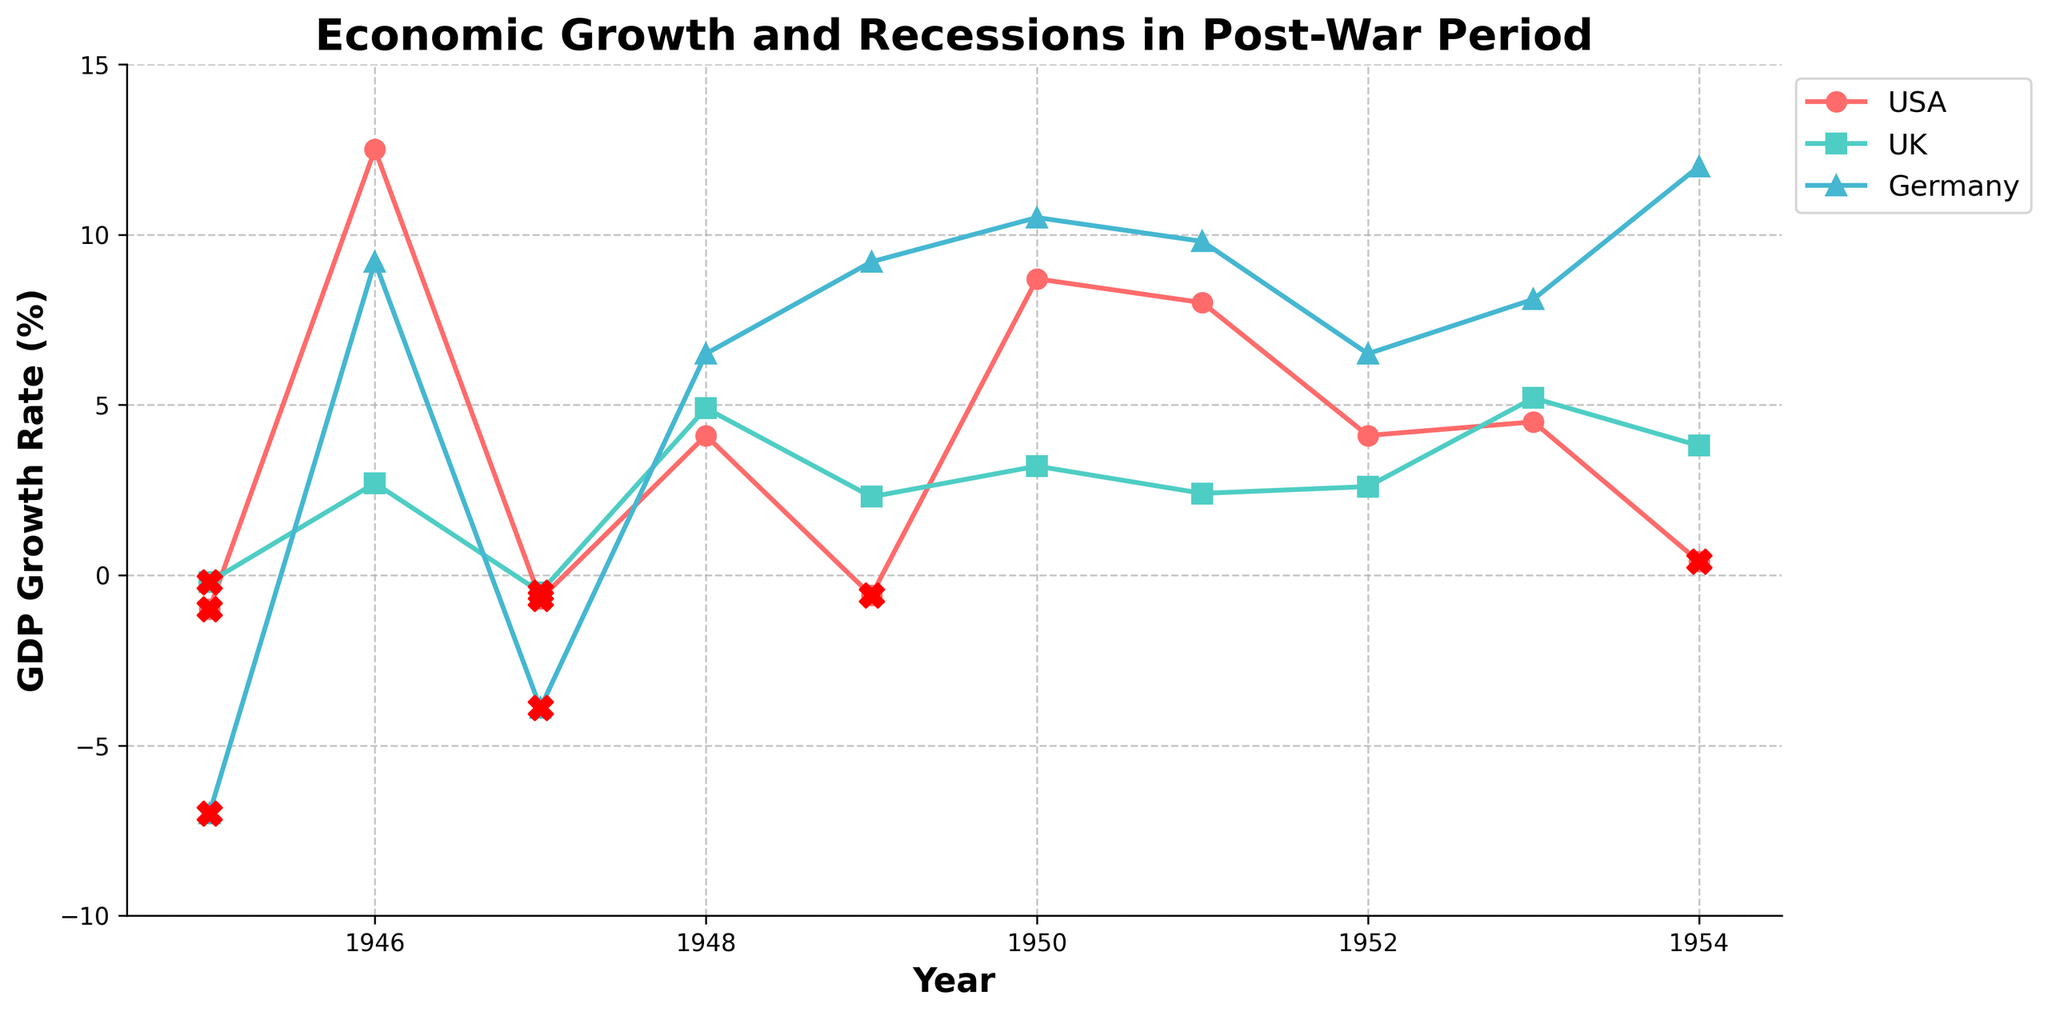What is the title of the figure? The title is written at the top of the figure, usually in bold text. It summarizes the main topic of the figure.
Answer: Economic Growth and Recessions in Post-War Period What does the x-axis represent? The x-axis is labeled with a specific term, and it usually represents a continuous variable. In this case, it covers a span of years.
Answer: Year What does the y-axis represent? The y-axis is labeled with a specific term that indicates what is being measured. Here, it shows the growth rate of GDP in percentage.
Answer: GDP Growth Rate (%) Which country experienced the highest GDP growth rate between 1945 and 1954? By looking at the highest peak in the plot for each country's line, we can determine the country with the greatest upward spike. The highest peak for Germany is 12.0% in 1954, which is higher than any peak for USA or UK.
Answer: Germany Was there any year when all three countries faced a recession post-war? Scatter points marked with 'X' in red indicate recession years. We need to check if there is any single year where 'X' marks are present for all three countries. We see that 1945 has recession marks for USA, UK, and Germany.
Answer: Yes, in 1945 Which country had the most frequent recessions during the post-war period from 1945 to 1954? The frequency of recessions can be determined by counting the number of 'X' marks for each country. USA has 4 recessions, UK has 2 recessions, and Germany has 2 recessions.
Answer: USA Compare the GDP growth rates of the USA and the UK in 1947. Locate the year 1947 on the x-axis and check the corresponding y-values for both the USA and the UK. The USA has a GDP growth rate of -0.7%, and the UK has -0.5%.
Answer: The UK's growth rate is higher In which year did Germany's GDP growth rate first turn positive after World War II? Start from 1945 and move forward along Germany's line until you find the first positive value. Germany's GDP growth rate first turns positive in 1946 and is 9.2%.
Answer: 1946 What are the GDP growth rates of the USA and Germany in 1950, and which one is higher? Locate the year 1950 on the x-axis and check the corresponding y-values for both the USA and Germany. USA has 8.7%, and Germany has 10.5%, so Germany's rate is higher.
Answer: Germany's rate is higher Which year shows the greatest decline in GDP growth rate for the USA, and what is the value? Look for the most significant drop on the USA's line. The greatest decline is from 12.5% in 1946 to -0.7% in 1947, a decline of approximately -13.2%.
Answer: Between 1946 and 1947, decline by 13.2% 